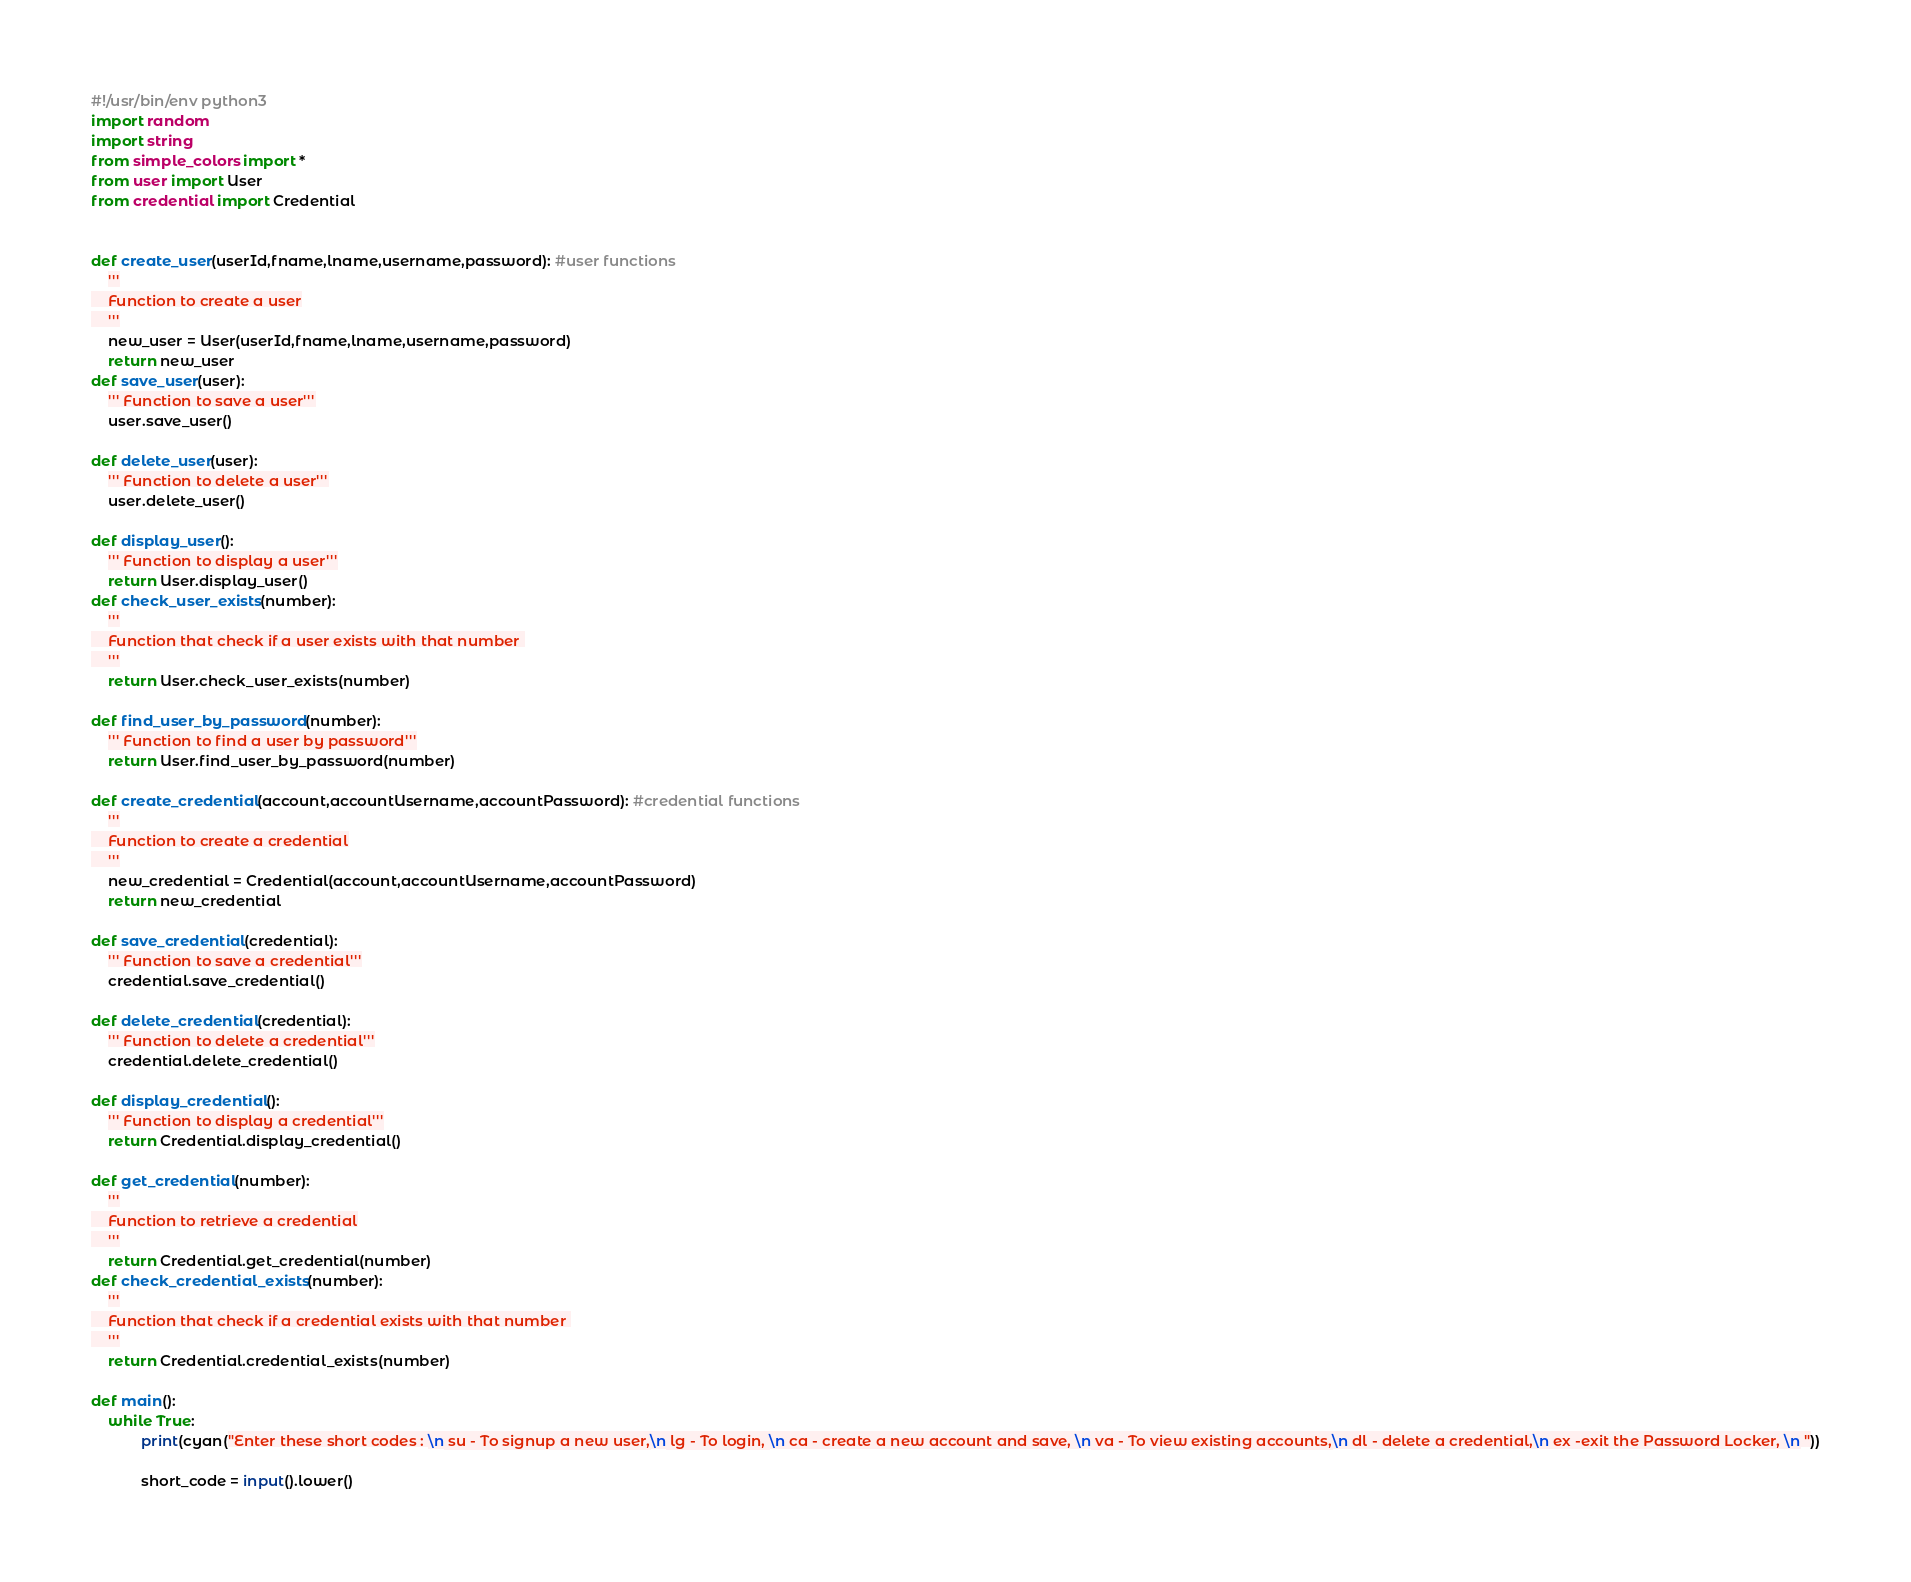<code> <loc_0><loc_0><loc_500><loc_500><_Python_>#!/usr/bin/env python3
import random
import string
from simple_colors import *
from user import User
from credential import Credential


def create_user(userId,fname,lname,username,password): #user functions
    '''
    Function to create a user
    '''
    new_user = User(userId,fname,lname,username,password)
    return new_user
def save_user(user):
    ''' Function to save a user'''
    user.save_user()
    
def delete_user(user):
    ''' Function to delete a user'''
    user.delete_user()

def display_user():
    ''' Function to display a user'''
    return User.display_user()
def check_user_exists(number):
    '''
    Function that check if a user exists with that number 
    '''
    return User.check_user_exists(number)

def find_user_by_password(number):
    ''' Function to find a user by password'''
    return User.find_user_by_password(number)

def create_credential(account,accountUsername,accountPassword): #credential functions
    '''
    Function to create a credential
    '''
    new_credential = Credential(account,accountUsername,accountPassword)
    return new_credential

def save_credential(credential):
    ''' Function to save a credential'''
    credential.save_credential()
    
def delete_credential(credential):
    ''' Function to delete a credential'''
    credential.delete_credential()

def display_credential():
    ''' Function to display a credential'''
    return Credential.display_credential()
    
def get_credential(number):
    '''
    Function to retrieve a credential
    '''
    return Credential.get_credential(number)
def check_credential_exists(number):
    '''
    Function that check if a credential exists with that number 
    '''
    return Credential.credential_exists(number)
    
def main():
    while True:
            print(cyan("Enter these short codes : \n su - To signup a new user,\n lg - To login, \n ca - create a new account and save, \n va - To view existing accounts,\n dl - delete a credential,\n ex -exit the Password Locker, \n "))

            short_code = input().lower()
</code> 